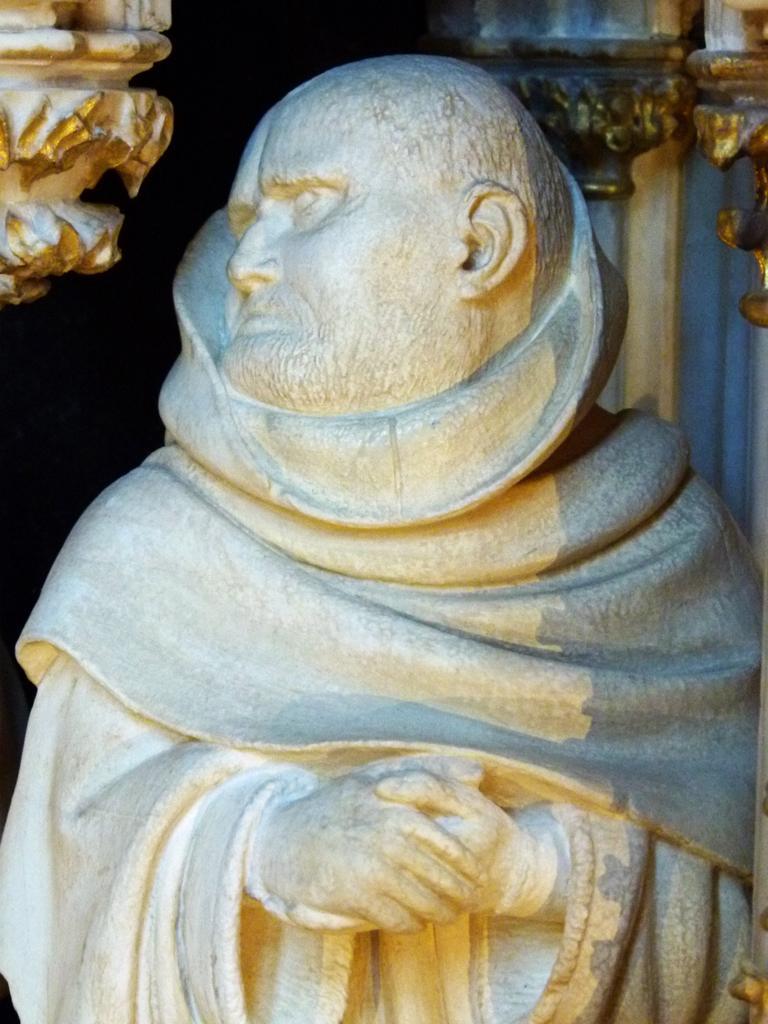Could you give a brief overview of what you see in this image? In this image we can see a statue of a man who is wrapped by a cloth and in the background of the image we can see some pillars which are in golden color. 